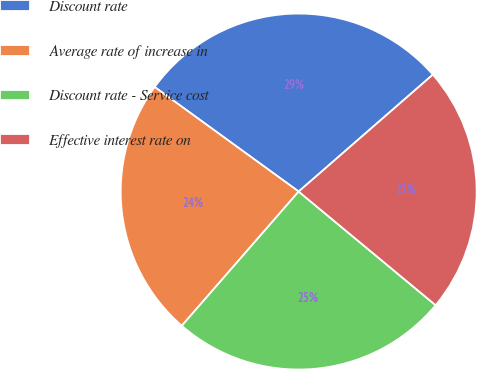<chart> <loc_0><loc_0><loc_500><loc_500><pie_chart><fcel>Discount rate<fcel>Average rate of increase in<fcel>Discount rate - Service cost<fcel>Effective interest rate on<nl><fcel>28.6%<fcel>23.59%<fcel>25.38%<fcel>22.43%<nl></chart> 